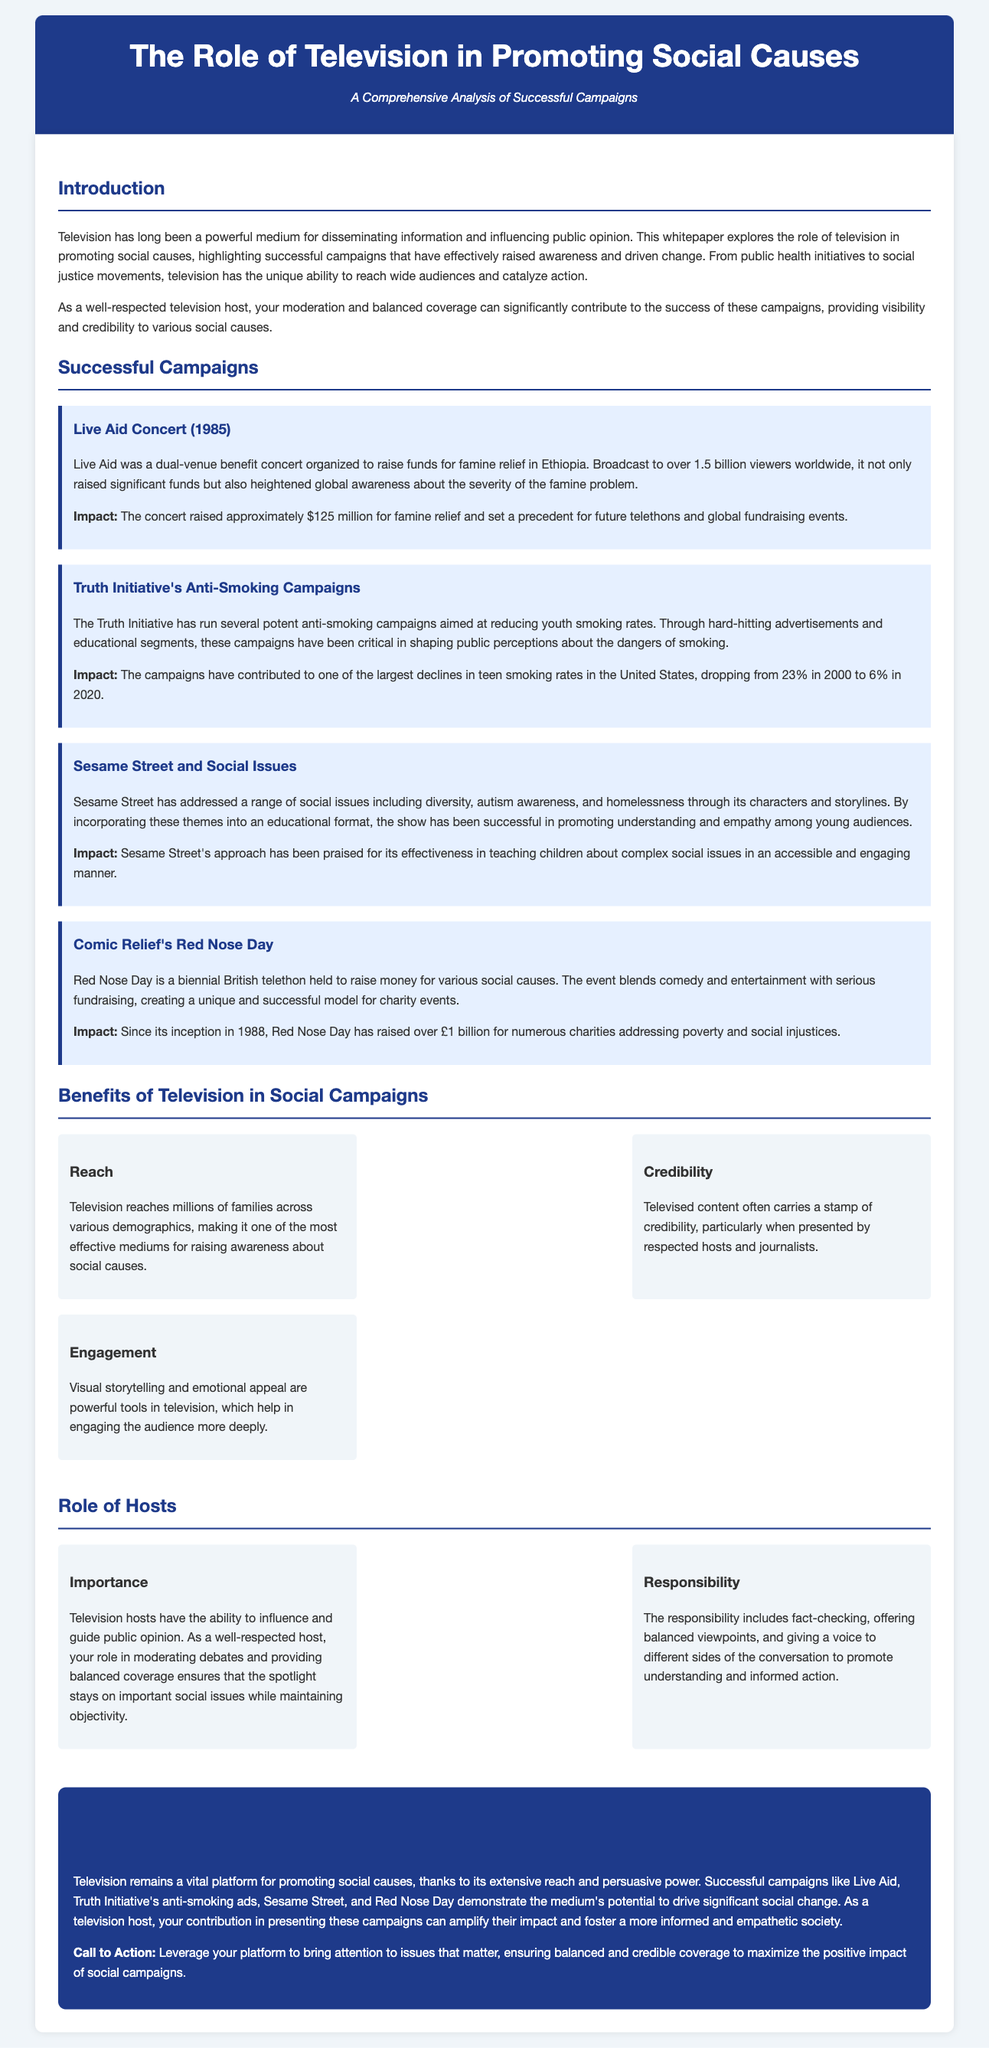What was the purpose of the Live Aid concert? The Live Aid concert was organized to raise funds for famine relief in Ethiopia.
Answer: famine relief How many viewers were reached by Live Aid? Live Aid was broadcast to over 1.5 billion viewers worldwide.
Answer: 1.5 billion What significant decline in teen smoking rates occurred between 2000 and 2020? The campaigns contributed to a decline from 23% in 2000 to 6% in 2020.
Answer: 17% What social issues has Sesame Street addressed? Sesame Street has addressed diversity, autism awareness, and homelessness.
Answer: diversity, autism awareness, homelessness Since its inception, how much has Red Nose Day raised for charities? Red Nose Day has raised over £1 billion for numerous charities addressing poverty and social injustices.
Answer: over £1 billion What is a key benefit of television in social campaigns? Television reaches millions of families across various demographics.
Answer: reach What is the importance of television hosts in campaigns? Hosts have the ability to influence and guide public opinion.
Answer: influence public opinion What is one responsibility of television hosts during social campaigns? The responsibility includes fact-checking and offering balanced viewpoints.
Answer: fact-checking Which campaign raised approximately $125 million for famine relief? The Live Aid concert raised approximately $125 million for famine relief.
Answer: Live Aid concert 